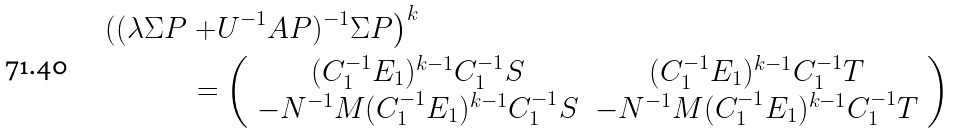<formula> <loc_0><loc_0><loc_500><loc_500>\left ( ( \lambda \Sigma P \right . & \left . + U ^ { - 1 } A P ) ^ { - 1 } \Sigma P \right ) ^ { k } \\ & = \left ( \begin{array} { c c } ( C _ { 1 } ^ { - 1 } E _ { 1 } ) ^ { k - 1 } C _ { 1 } ^ { - 1 } S & ( C _ { 1 } ^ { - 1 } E _ { 1 } ) ^ { k - 1 } C _ { 1 } ^ { - 1 } T \\ - N ^ { - 1 } M ( C _ { 1 } ^ { - 1 } E _ { 1 } ) ^ { k - 1 } C _ { 1 } ^ { - 1 } S & - N ^ { - 1 } M ( C _ { 1 } ^ { - 1 } E _ { 1 } ) ^ { k - 1 } C _ { 1 } ^ { - 1 } T \end{array} \right )</formula> 